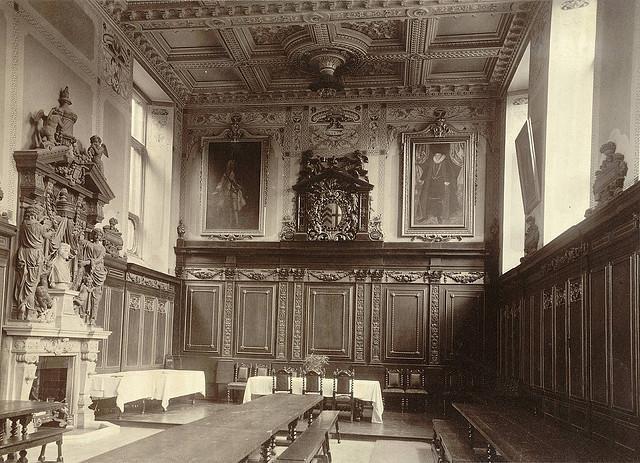How many paintings are on the wall?
Give a very brief answer. 2. How many people probably sleep here?
Give a very brief answer. 0. How many dining tables are in the picture?
Give a very brief answer. 3. 